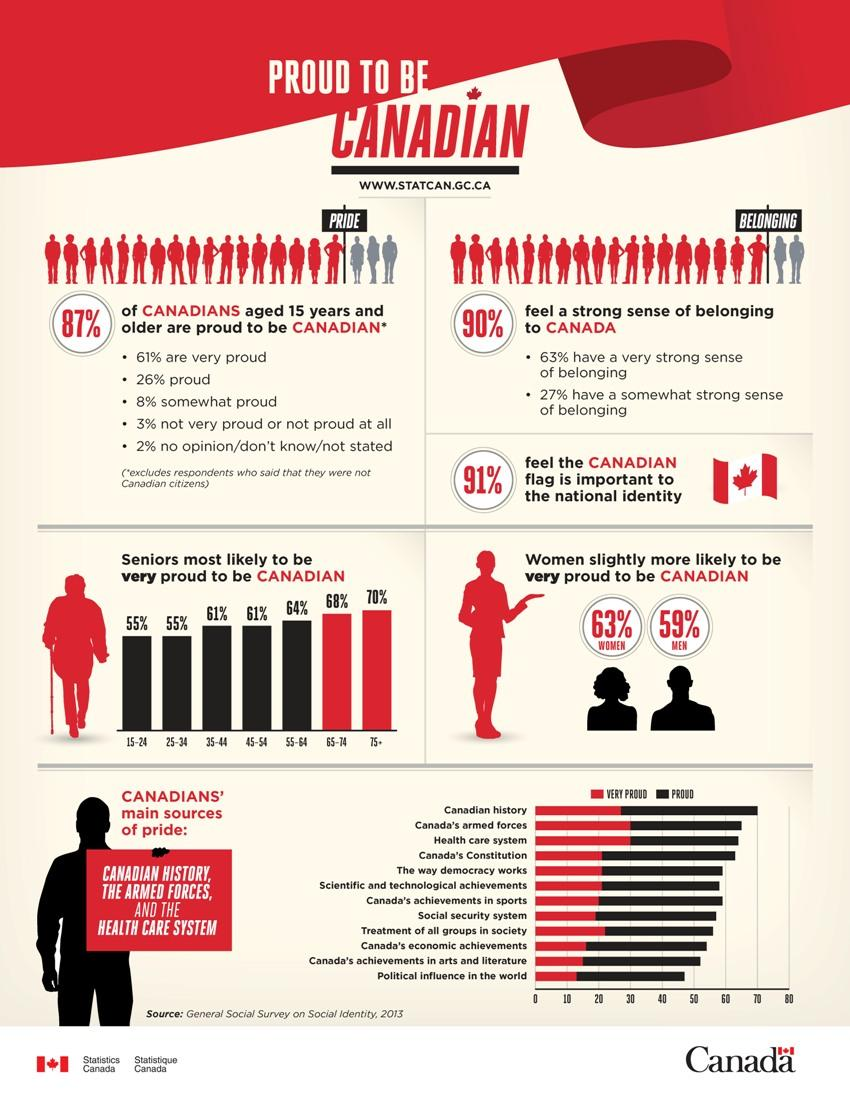Give some essential details in this illustration. According to the survey conducted in 2013 among respondents aged 25-34, 55% of them claimed to be proud to be Canadian. According to a survey conducted in 2013, 9% of respondents did not feel that the Canadian flag is important to the national identity. According to the General Social Survey on Social Identity in 2013, 63% of women reported feeling very proud to be Canadian. 